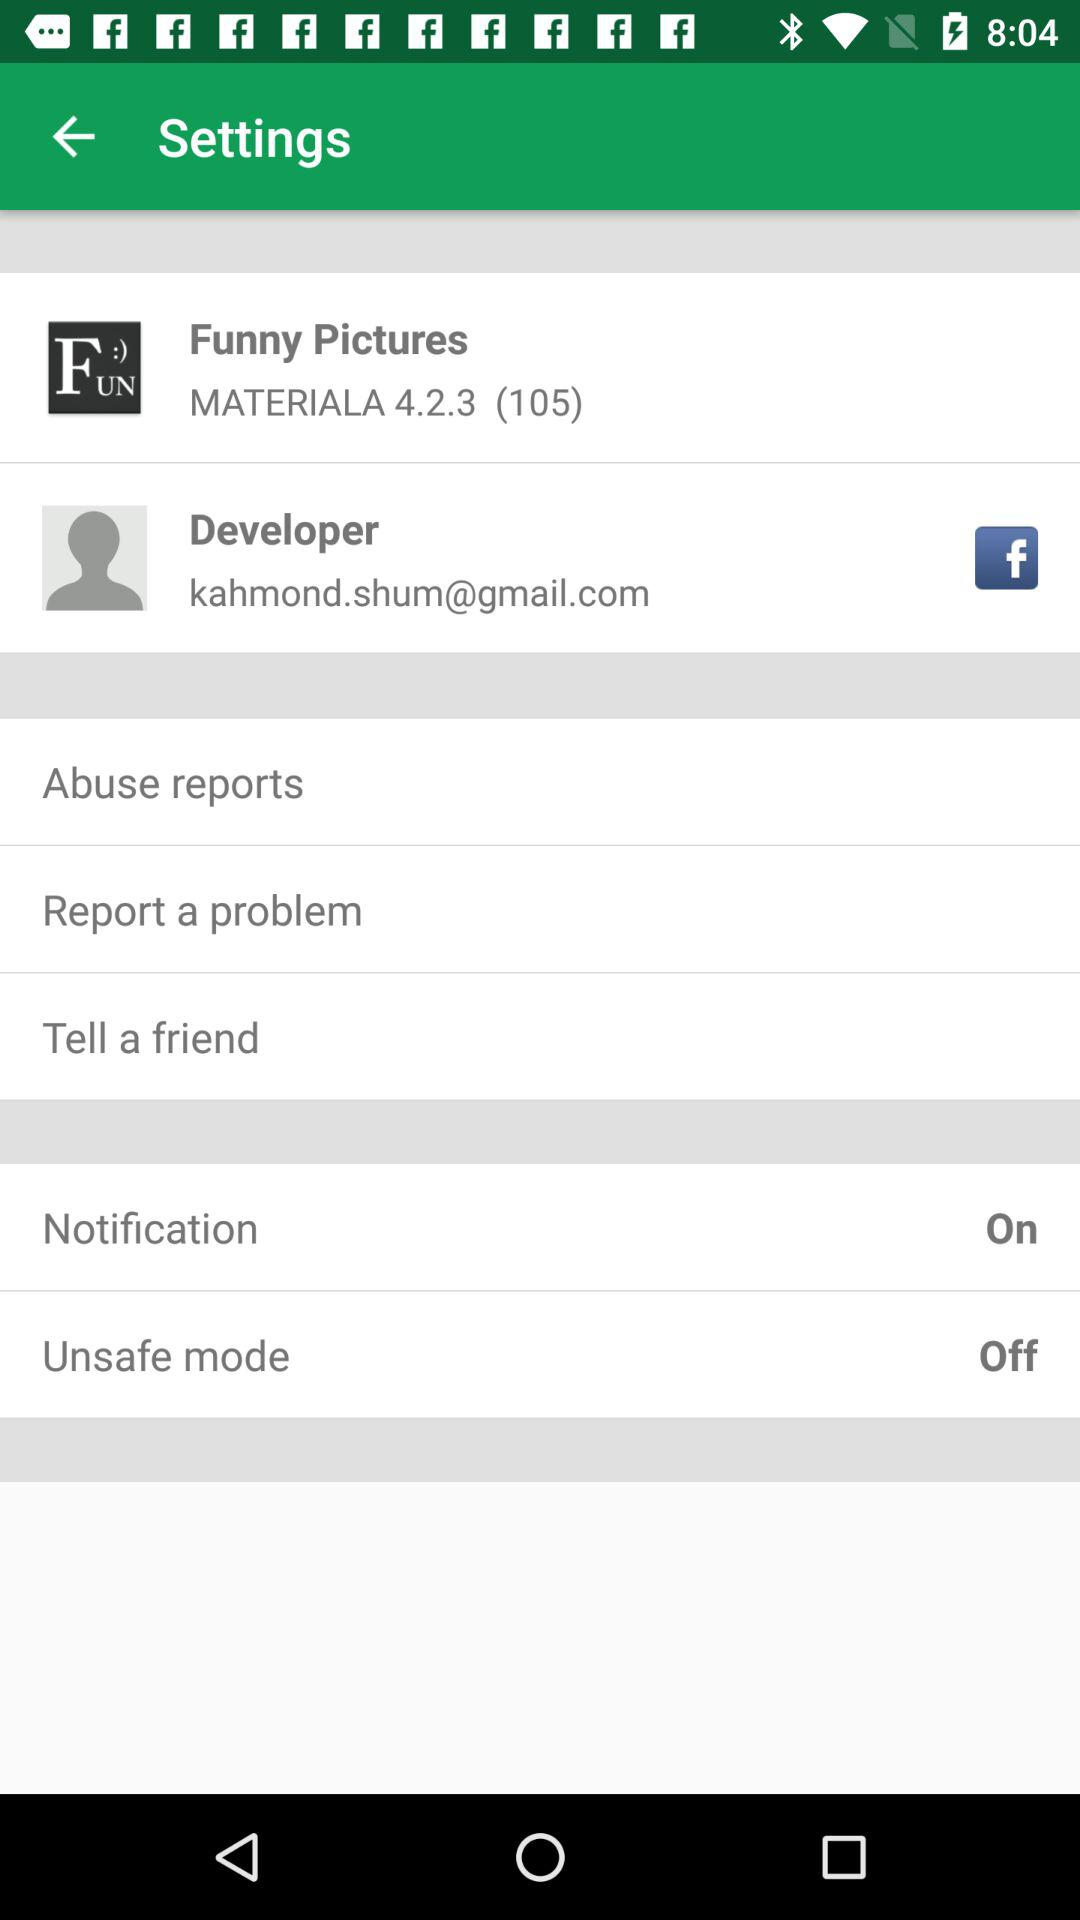What is the email address? The email address is kahmond.shum@gmail.com. 